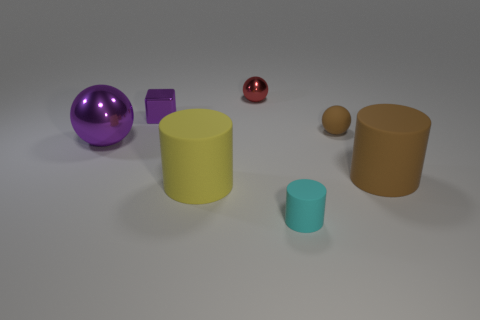There is a large thing left of the yellow object; what is its material?
Your response must be concise. Metal. Are there the same number of tiny matte objects in front of the tiny brown object and tiny purple metallic cubes that are on the right side of the small matte cylinder?
Provide a short and direct response. No. What is the color of the tiny metallic thing that is the same shape as the tiny brown matte thing?
Offer a terse response. Red. Is there anything else of the same color as the small cylinder?
Your answer should be very brief. No. How many shiny objects are small purple cubes or large brown cylinders?
Your answer should be compact. 1. Do the large metal sphere and the small cube have the same color?
Provide a short and direct response. Yes. Is the number of big cylinders that are left of the small cyan object greater than the number of large red cubes?
Ensure brevity in your answer.  Yes. What number of other objects are there of the same material as the large purple thing?
Your answer should be very brief. 2. What number of tiny things are either brown rubber cylinders or blocks?
Provide a succinct answer. 1. Does the big yellow cylinder have the same material as the tiny brown ball?
Offer a terse response. Yes. 